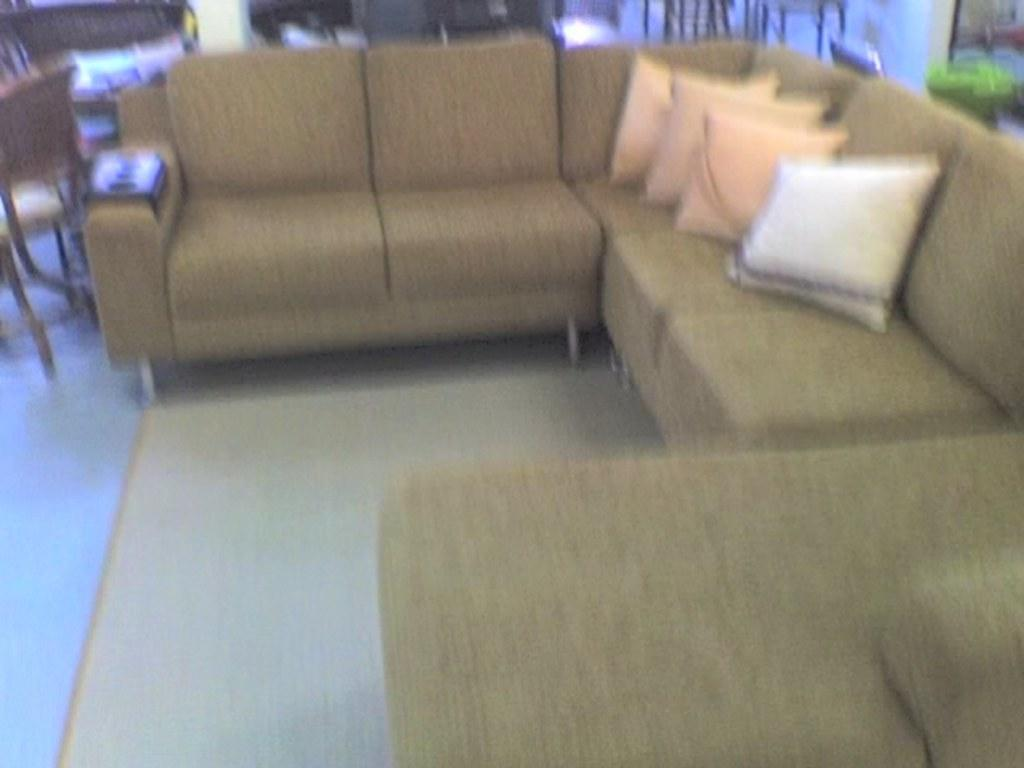What type of furniture is present in the room? There is a sofa set in the room. What is placed on the sofa? Pillows are placed on the sofa. Is there any additional seating in the room? Yes, there is a chair beside the sofa. What type of church can be seen in the image? There is no church present in the image; it features a sofa set, pillows, and a chair. What type of line is visible on the sofa? There is no line visible on the sofa in the image. 